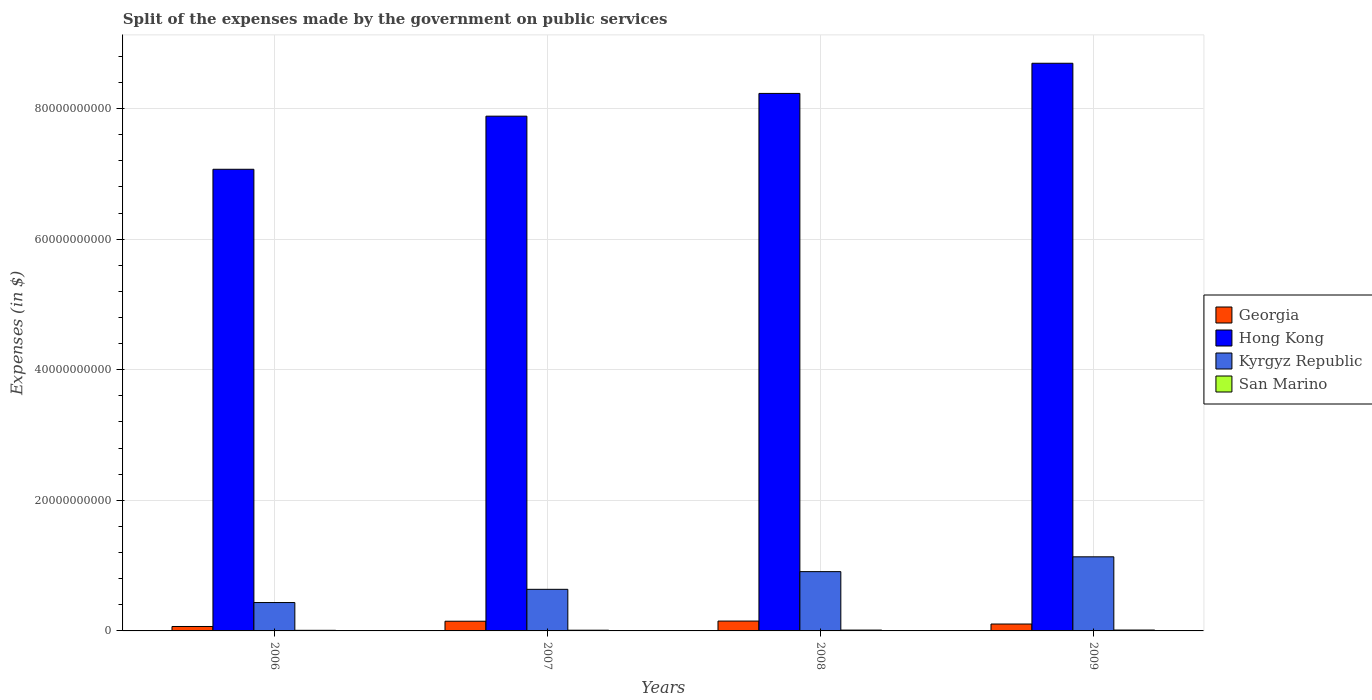Are the number of bars per tick equal to the number of legend labels?
Your answer should be very brief. Yes. What is the expenses made by the government on public services in Georgia in 2007?
Your answer should be very brief. 1.48e+09. Across all years, what is the maximum expenses made by the government on public services in Kyrgyz Republic?
Provide a short and direct response. 1.13e+1. Across all years, what is the minimum expenses made by the government on public services in Kyrgyz Republic?
Your answer should be compact. 4.35e+09. What is the total expenses made by the government on public services in San Marino in the graph?
Your response must be concise. 4.66e+08. What is the difference between the expenses made by the government on public services in San Marino in 2006 and that in 2009?
Offer a very short reply. -4.30e+07. What is the difference between the expenses made by the government on public services in Georgia in 2008 and the expenses made by the government on public services in Hong Kong in 2006?
Your answer should be very brief. -6.92e+1. What is the average expenses made by the government on public services in San Marino per year?
Give a very brief answer. 1.17e+08. In the year 2007, what is the difference between the expenses made by the government on public services in Georgia and expenses made by the government on public services in Hong Kong?
Keep it short and to the point. -7.73e+1. What is the ratio of the expenses made by the government on public services in Georgia in 2007 to that in 2008?
Provide a succinct answer. 0.98. What is the difference between the highest and the second highest expenses made by the government on public services in Georgia?
Your answer should be very brief. 2.49e+07. What is the difference between the highest and the lowest expenses made by the government on public services in Kyrgyz Republic?
Offer a very short reply. 7.00e+09. In how many years, is the expenses made by the government on public services in Hong Kong greater than the average expenses made by the government on public services in Hong Kong taken over all years?
Your answer should be compact. 2. What does the 4th bar from the left in 2009 represents?
Ensure brevity in your answer.  San Marino. What does the 2nd bar from the right in 2006 represents?
Offer a terse response. Kyrgyz Republic. How many bars are there?
Make the answer very short. 16. Are all the bars in the graph horizontal?
Ensure brevity in your answer.  No. How many years are there in the graph?
Offer a very short reply. 4. Does the graph contain grids?
Keep it short and to the point. Yes. How are the legend labels stacked?
Give a very brief answer. Vertical. What is the title of the graph?
Offer a very short reply. Split of the expenses made by the government on public services. Does "Syrian Arab Republic" appear as one of the legend labels in the graph?
Your answer should be compact. No. What is the label or title of the X-axis?
Your answer should be very brief. Years. What is the label or title of the Y-axis?
Your response must be concise. Expenses (in $). What is the Expenses (in $) in Georgia in 2006?
Offer a terse response. 6.78e+08. What is the Expenses (in $) of Hong Kong in 2006?
Your response must be concise. 7.07e+1. What is the Expenses (in $) of Kyrgyz Republic in 2006?
Your answer should be very brief. 4.35e+09. What is the Expenses (in $) of San Marino in 2006?
Your response must be concise. 9.27e+07. What is the Expenses (in $) of Georgia in 2007?
Provide a short and direct response. 1.48e+09. What is the Expenses (in $) of Hong Kong in 2007?
Your answer should be very brief. 7.88e+1. What is the Expenses (in $) of Kyrgyz Republic in 2007?
Ensure brevity in your answer.  6.37e+09. What is the Expenses (in $) in San Marino in 2007?
Your answer should be compact. 1.09e+08. What is the Expenses (in $) in Georgia in 2008?
Your response must be concise. 1.51e+09. What is the Expenses (in $) of Hong Kong in 2008?
Provide a short and direct response. 8.23e+1. What is the Expenses (in $) in Kyrgyz Republic in 2008?
Offer a very short reply. 9.08e+09. What is the Expenses (in $) of San Marino in 2008?
Make the answer very short. 1.29e+08. What is the Expenses (in $) of Georgia in 2009?
Offer a terse response. 1.06e+09. What is the Expenses (in $) of Hong Kong in 2009?
Provide a succinct answer. 8.69e+1. What is the Expenses (in $) in Kyrgyz Republic in 2009?
Offer a very short reply. 1.13e+1. What is the Expenses (in $) in San Marino in 2009?
Make the answer very short. 1.36e+08. Across all years, what is the maximum Expenses (in $) in Georgia?
Keep it short and to the point. 1.51e+09. Across all years, what is the maximum Expenses (in $) of Hong Kong?
Offer a very short reply. 8.69e+1. Across all years, what is the maximum Expenses (in $) of Kyrgyz Republic?
Ensure brevity in your answer.  1.13e+1. Across all years, what is the maximum Expenses (in $) of San Marino?
Your answer should be compact. 1.36e+08. Across all years, what is the minimum Expenses (in $) of Georgia?
Provide a succinct answer. 6.78e+08. Across all years, what is the minimum Expenses (in $) in Hong Kong?
Your response must be concise. 7.07e+1. Across all years, what is the minimum Expenses (in $) of Kyrgyz Republic?
Your answer should be compact. 4.35e+09. Across all years, what is the minimum Expenses (in $) of San Marino?
Your answer should be very brief. 9.27e+07. What is the total Expenses (in $) of Georgia in the graph?
Keep it short and to the point. 4.73e+09. What is the total Expenses (in $) of Hong Kong in the graph?
Ensure brevity in your answer.  3.19e+11. What is the total Expenses (in $) in Kyrgyz Republic in the graph?
Provide a succinct answer. 3.11e+1. What is the total Expenses (in $) in San Marino in the graph?
Keep it short and to the point. 4.66e+08. What is the difference between the Expenses (in $) of Georgia in 2006 and that in 2007?
Provide a short and direct response. -8.05e+08. What is the difference between the Expenses (in $) in Hong Kong in 2006 and that in 2007?
Give a very brief answer. -8.13e+09. What is the difference between the Expenses (in $) in Kyrgyz Republic in 2006 and that in 2007?
Offer a very short reply. -2.02e+09. What is the difference between the Expenses (in $) in San Marino in 2006 and that in 2007?
Offer a terse response. -1.60e+07. What is the difference between the Expenses (in $) of Georgia in 2006 and that in 2008?
Your response must be concise. -8.30e+08. What is the difference between the Expenses (in $) in Hong Kong in 2006 and that in 2008?
Keep it short and to the point. -1.16e+1. What is the difference between the Expenses (in $) of Kyrgyz Republic in 2006 and that in 2008?
Your response must be concise. -4.73e+09. What is the difference between the Expenses (in $) in San Marino in 2006 and that in 2008?
Your response must be concise. -3.64e+07. What is the difference between the Expenses (in $) of Georgia in 2006 and that in 2009?
Provide a succinct answer. -3.77e+08. What is the difference between the Expenses (in $) of Hong Kong in 2006 and that in 2009?
Provide a short and direct response. -1.62e+1. What is the difference between the Expenses (in $) in Kyrgyz Republic in 2006 and that in 2009?
Make the answer very short. -7.00e+09. What is the difference between the Expenses (in $) in San Marino in 2006 and that in 2009?
Your answer should be compact. -4.30e+07. What is the difference between the Expenses (in $) in Georgia in 2007 and that in 2008?
Make the answer very short. -2.49e+07. What is the difference between the Expenses (in $) in Hong Kong in 2007 and that in 2008?
Your answer should be very brief. -3.48e+09. What is the difference between the Expenses (in $) of Kyrgyz Republic in 2007 and that in 2008?
Ensure brevity in your answer.  -2.71e+09. What is the difference between the Expenses (in $) of San Marino in 2007 and that in 2008?
Your answer should be very brief. -2.04e+07. What is the difference between the Expenses (in $) in Georgia in 2007 and that in 2009?
Offer a terse response. 4.29e+08. What is the difference between the Expenses (in $) in Hong Kong in 2007 and that in 2009?
Ensure brevity in your answer.  -8.10e+09. What is the difference between the Expenses (in $) of Kyrgyz Republic in 2007 and that in 2009?
Your answer should be compact. -4.98e+09. What is the difference between the Expenses (in $) in San Marino in 2007 and that in 2009?
Offer a very short reply. -2.70e+07. What is the difference between the Expenses (in $) in Georgia in 2008 and that in 2009?
Give a very brief answer. 4.54e+08. What is the difference between the Expenses (in $) of Hong Kong in 2008 and that in 2009?
Your answer should be very brief. -4.62e+09. What is the difference between the Expenses (in $) of Kyrgyz Republic in 2008 and that in 2009?
Make the answer very short. -2.27e+09. What is the difference between the Expenses (in $) of San Marino in 2008 and that in 2009?
Make the answer very short. -6.65e+06. What is the difference between the Expenses (in $) in Georgia in 2006 and the Expenses (in $) in Hong Kong in 2007?
Ensure brevity in your answer.  -7.82e+1. What is the difference between the Expenses (in $) in Georgia in 2006 and the Expenses (in $) in Kyrgyz Republic in 2007?
Offer a terse response. -5.69e+09. What is the difference between the Expenses (in $) in Georgia in 2006 and the Expenses (in $) in San Marino in 2007?
Provide a short and direct response. 5.70e+08. What is the difference between the Expenses (in $) in Hong Kong in 2006 and the Expenses (in $) in Kyrgyz Republic in 2007?
Provide a short and direct response. 6.43e+1. What is the difference between the Expenses (in $) of Hong Kong in 2006 and the Expenses (in $) of San Marino in 2007?
Give a very brief answer. 7.06e+1. What is the difference between the Expenses (in $) in Kyrgyz Republic in 2006 and the Expenses (in $) in San Marino in 2007?
Offer a terse response. 4.24e+09. What is the difference between the Expenses (in $) of Georgia in 2006 and the Expenses (in $) of Hong Kong in 2008?
Your answer should be very brief. -8.16e+1. What is the difference between the Expenses (in $) in Georgia in 2006 and the Expenses (in $) in Kyrgyz Republic in 2008?
Your answer should be compact. -8.40e+09. What is the difference between the Expenses (in $) in Georgia in 2006 and the Expenses (in $) in San Marino in 2008?
Your response must be concise. 5.49e+08. What is the difference between the Expenses (in $) of Hong Kong in 2006 and the Expenses (in $) of Kyrgyz Republic in 2008?
Ensure brevity in your answer.  6.16e+1. What is the difference between the Expenses (in $) of Hong Kong in 2006 and the Expenses (in $) of San Marino in 2008?
Provide a short and direct response. 7.06e+1. What is the difference between the Expenses (in $) in Kyrgyz Republic in 2006 and the Expenses (in $) in San Marino in 2008?
Make the answer very short. 4.22e+09. What is the difference between the Expenses (in $) of Georgia in 2006 and the Expenses (in $) of Hong Kong in 2009?
Your response must be concise. -8.63e+1. What is the difference between the Expenses (in $) of Georgia in 2006 and the Expenses (in $) of Kyrgyz Republic in 2009?
Give a very brief answer. -1.07e+1. What is the difference between the Expenses (in $) in Georgia in 2006 and the Expenses (in $) in San Marino in 2009?
Give a very brief answer. 5.43e+08. What is the difference between the Expenses (in $) of Hong Kong in 2006 and the Expenses (in $) of Kyrgyz Republic in 2009?
Your answer should be compact. 5.93e+1. What is the difference between the Expenses (in $) of Hong Kong in 2006 and the Expenses (in $) of San Marino in 2009?
Keep it short and to the point. 7.06e+1. What is the difference between the Expenses (in $) in Kyrgyz Republic in 2006 and the Expenses (in $) in San Marino in 2009?
Provide a short and direct response. 4.21e+09. What is the difference between the Expenses (in $) of Georgia in 2007 and the Expenses (in $) of Hong Kong in 2008?
Offer a very short reply. -8.08e+1. What is the difference between the Expenses (in $) in Georgia in 2007 and the Expenses (in $) in Kyrgyz Republic in 2008?
Ensure brevity in your answer.  -7.60e+09. What is the difference between the Expenses (in $) in Georgia in 2007 and the Expenses (in $) in San Marino in 2008?
Your answer should be very brief. 1.35e+09. What is the difference between the Expenses (in $) of Hong Kong in 2007 and the Expenses (in $) of Kyrgyz Republic in 2008?
Give a very brief answer. 6.98e+1. What is the difference between the Expenses (in $) in Hong Kong in 2007 and the Expenses (in $) in San Marino in 2008?
Make the answer very short. 7.87e+1. What is the difference between the Expenses (in $) of Kyrgyz Republic in 2007 and the Expenses (in $) of San Marino in 2008?
Ensure brevity in your answer.  6.24e+09. What is the difference between the Expenses (in $) of Georgia in 2007 and the Expenses (in $) of Hong Kong in 2009?
Make the answer very short. -8.54e+1. What is the difference between the Expenses (in $) of Georgia in 2007 and the Expenses (in $) of Kyrgyz Republic in 2009?
Offer a terse response. -9.86e+09. What is the difference between the Expenses (in $) of Georgia in 2007 and the Expenses (in $) of San Marino in 2009?
Offer a terse response. 1.35e+09. What is the difference between the Expenses (in $) of Hong Kong in 2007 and the Expenses (in $) of Kyrgyz Republic in 2009?
Offer a terse response. 6.75e+1. What is the difference between the Expenses (in $) of Hong Kong in 2007 and the Expenses (in $) of San Marino in 2009?
Provide a succinct answer. 7.87e+1. What is the difference between the Expenses (in $) of Kyrgyz Republic in 2007 and the Expenses (in $) of San Marino in 2009?
Keep it short and to the point. 6.23e+09. What is the difference between the Expenses (in $) in Georgia in 2008 and the Expenses (in $) in Hong Kong in 2009?
Offer a very short reply. -8.54e+1. What is the difference between the Expenses (in $) of Georgia in 2008 and the Expenses (in $) of Kyrgyz Republic in 2009?
Ensure brevity in your answer.  -9.84e+09. What is the difference between the Expenses (in $) of Georgia in 2008 and the Expenses (in $) of San Marino in 2009?
Ensure brevity in your answer.  1.37e+09. What is the difference between the Expenses (in $) of Hong Kong in 2008 and the Expenses (in $) of Kyrgyz Republic in 2009?
Give a very brief answer. 7.10e+1. What is the difference between the Expenses (in $) in Hong Kong in 2008 and the Expenses (in $) in San Marino in 2009?
Provide a succinct answer. 8.22e+1. What is the difference between the Expenses (in $) in Kyrgyz Republic in 2008 and the Expenses (in $) in San Marino in 2009?
Make the answer very short. 8.94e+09. What is the average Expenses (in $) in Georgia per year?
Offer a terse response. 1.18e+09. What is the average Expenses (in $) of Hong Kong per year?
Keep it short and to the point. 7.97e+1. What is the average Expenses (in $) in Kyrgyz Republic per year?
Make the answer very short. 7.79e+09. What is the average Expenses (in $) in San Marino per year?
Your response must be concise. 1.17e+08. In the year 2006, what is the difference between the Expenses (in $) of Georgia and Expenses (in $) of Hong Kong?
Give a very brief answer. -7.00e+1. In the year 2006, what is the difference between the Expenses (in $) of Georgia and Expenses (in $) of Kyrgyz Republic?
Keep it short and to the point. -3.67e+09. In the year 2006, what is the difference between the Expenses (in $) in Georgia and Expenses (in $) in San Marino?
Your answer should be compact. 5.86e+08. In the year 2006, what is the difference between the Expenses (in $) of Hong Kong and Expenses (in $) of Kyrgyz Republic?
Make the answer very short. 6.64e+1. In the year 2006, what is the difference between the Expenses (in $) in Hong Kong and Expenses (in $) in San Marino?
Offer a very short reply. 7.06e+1. In the year 2006, what is the difference between the Expenses (in $) of Kyrgyz Republic and Expenses (in $) of San Marino?
Ensure brevity in your answer.  4.25e+09. In the year 2007, what is the difference between the Expenses (in $) of Georgia and Expenses (in $) of Hong Kong?
Your response must be concise. -7.73e+1. In the year 2007, what is the difference between the Expenses (in $) in Georgia and Expenses (in $) in Kyrgyz Republic?
Make the answer very short. -4.89e+09. In the year 2007, what is the difference between the Expenses (in $) in Georgia and Expenses (in $) in San Marino?
Give a very brief answer. 1.38e+09. In the year 2007, what is the difference between the Expenses (in $) in Hong Kong and Expenses (in $) in Kyrgyz Republic?
Provide a short and direct response. 7.25e+1. In the year 2007, what is the difference between the Expenses (in $) of Hong Kong and Expenses (in $) of San Marino?
Your answer should be compact. 7.87e+1. In the year 2007, what is the difference between the Expenses (in $) in Kyrgyz Republic and Expenses (in $) in San Marino?
Provide a short and direct response. 6.26e+09. In the year 2008, what is the difference between the Expenses (in $) of Georgia and Expenses (in $) of Hong Kong?
Provide a succinct answer. -8.08e+1. In the year 2008, what is the difference between the Expenses (in $) in Georgia and Expenses (in $) in Kyrgyz Republic?
Your answer should be very brief. -7.57e+09. In the year 2008, what is the difference between the Expenses (in $) of Georgia and Expenses (in $) of San Marino?
Keep it short and to the point. 1.38e+09. In the year 2008, what is the difference between the Expenses (in $) of Hong Kong and Expenses (in $) of Kyrgyz Republic?
Your answer should be very brief. 7.32e+1. In the year 2008, what is the difference between the Expenses (in $) in Hong Kong and Expenses (in $) in San Marino?
Make the answer very short. 8.22e+1. In the year 2008, what is the difference between the Expenses (in $) of Kyrgyz Republic and Expenses (in $) of San Marino?
Give a very brief answer. 8.95e+09. In the year 2009, what is the difference between the Expenses (in $) in Georgia and Expenses (in $) in Hong Kong?
Ensure brevity in your answer.  -8.59e+1. In the year 2009, what is the difference between the Expenses (in $) in Georgia and Expenses (in $) in Kyrgyz Republic?
Provide a short and direct response. -1.03e+1. In the year 2009, what is the difference between the Expenses (in $) of Georgia and Expenses (in $) of San Marino?
Your response must be concise. 9.19e+08. In the year 2009, what is the difference between the Expenses (in $) in Hong Kong and Expenses (in $) in Kyrgyz Republic?
Your response must be concise. 7.56e+1. In the year 2009, what is the difference between the Expenses (in $) of Hong Kong and Expenses (in $) of San Marino?
Provide a short and direct response. 8.68e+1. In the year 2009, what is the difference between the Expenses (in $) of Kyrgyz Republic and Expenses (in $) of San Marino?
Provide a succinct answer. 1.12e+1. What is the ratio of the Expenses (in $) in Georgia in 2006 to that in 2007?
Offer a very short reply. 0.46. What is the ratio of the Expenses (in $) of Hong Kong in 2006 to that in 2007?
Offer a very short reply. 0.9. What is the ratio of the Expenses (in $) of Kyrgyz Republic in 2006 to that in 2007?
Make the answer very short. 0.68. What is the ratio of the Expenses (in $) of San Marino in 2006 to that in 2007?
Your answer should be compact. 0.85. What is the ratio of the Expenses (in $) of Georgia in 2006 to that in 2008?
Give a very brief answer. 0.45. What is the ratio of the Expenses (in $) of Hong Kong in 2006 to that in 2008?
Your answer should be compact. 0.86. What is the ratio of the Expenses (in $) in Kyrgyz Republic in 2006 to that in 2008?
Offer a very short reply. 0.48. What is the ratio of the Expenses (in $) of San Marino in 2006 to that in 2008?
Offer a very short reply. 0.72. What is the ratio of the Expenses (in $) of Georgia in 2006 to that in 2009?
Your answer should be very brief. 0.64. What is the ratio of the Expenses (in $) of Hong Kong in 2006 to that in 2009?
Your answer should be compact. 0.81. What is the ratio of the Expenses (in $) of Kyrgyz Republic in 2006 to that in 2009?
Your response must be concise. 0.38. What is the ratio of the Expenses (in $) of San Marino in 2006 to that in 2009?
Your answer should be compact. 0.68. What is the ratio of the Expenses (in $) of Georgia in 2007 to that in 2008?
Ensure brevity in your answer.  0.98. What is the ratio of the Expenses (in $) of Hong Kong in 2007 to that in 2008?
Your answer should be very brief. 0.96. What is the ratio of the Expenses (in $) in Kyrgyz Republic in 2007 to that in 2008?
Your answer should be very brief. 0.7. What is the ratio of the Expenses (in $) of San Marino in 2007 to that in 2008?
Offer a very short reply. 0.84. What is the ratio of the Expenses (in $) in Georgia in 2007 to that in 2009?
Your answer should be compact. 1.41. What is the ratio of the Expenses (in $) of Hong Kong in 2007 to that in 2009?
Your answer should be very brief. 0.91. What is the ratio of the Expenses (in $) of Kyrgyz Republic in 2007 to that in 2009?
Keep it short and to the point. 0.56. What is the ratio of the Expenses (in $) of San Marino in 2007 to that in 2009?
Make the answer very short. 0.8. What is the ratio of the Expenses (in $) of Georgia in 2008 to that in 2009?
Your answer should be compact. 1.43. What is the ratio of the Expenses (in $) of Hong Kong in 2008 to that in 2009?
Give a very brief answer. 0.95. What is the ratio of the Expenses (in $) in Kyrgyz Republic in 2008 to that in 2009?
Your answer should be very brief. 0.8. What is the ratio of the Expenses (in $) of San Marino in 2008 to that in 2009?
Give a very brief answer. 0.95. What is the difference between the highest and the second highest Expenses (in $) in Georgia?
Your answer should be compact. 2.49e+07. What is the difference between the highest and the second highest Expenses (in $) in Hong Kong?
Your answer should be very brief. 4.62e+09. What is the difference between the highest and the second highest Expenses (in $) in Kyrgyz Republic?
Offer a very short reply. 2.27e+09. What is the difference between the highest and the second highest Expenses (in $) of San Marino?
Provide a succinct answer. 6.65e+06. What is the difference between the highest and the lowest Expenses (in $) of Georgia?
Your answer should be compact. 8.30e+08. What is the difference between the highest and the lowest Expenses (in $) in Hong Kong?
Offer a terse response. 1.62e+1. What is the difference between the highest and the lowest Expenses (in $) of Kyrgyz Republic?
Give a very brief answer. 7.00e+09. What is the difference between the highest and the lowest Expenses (in $) in San Marino?
Provide a succinct answer. 4.30e+07. 